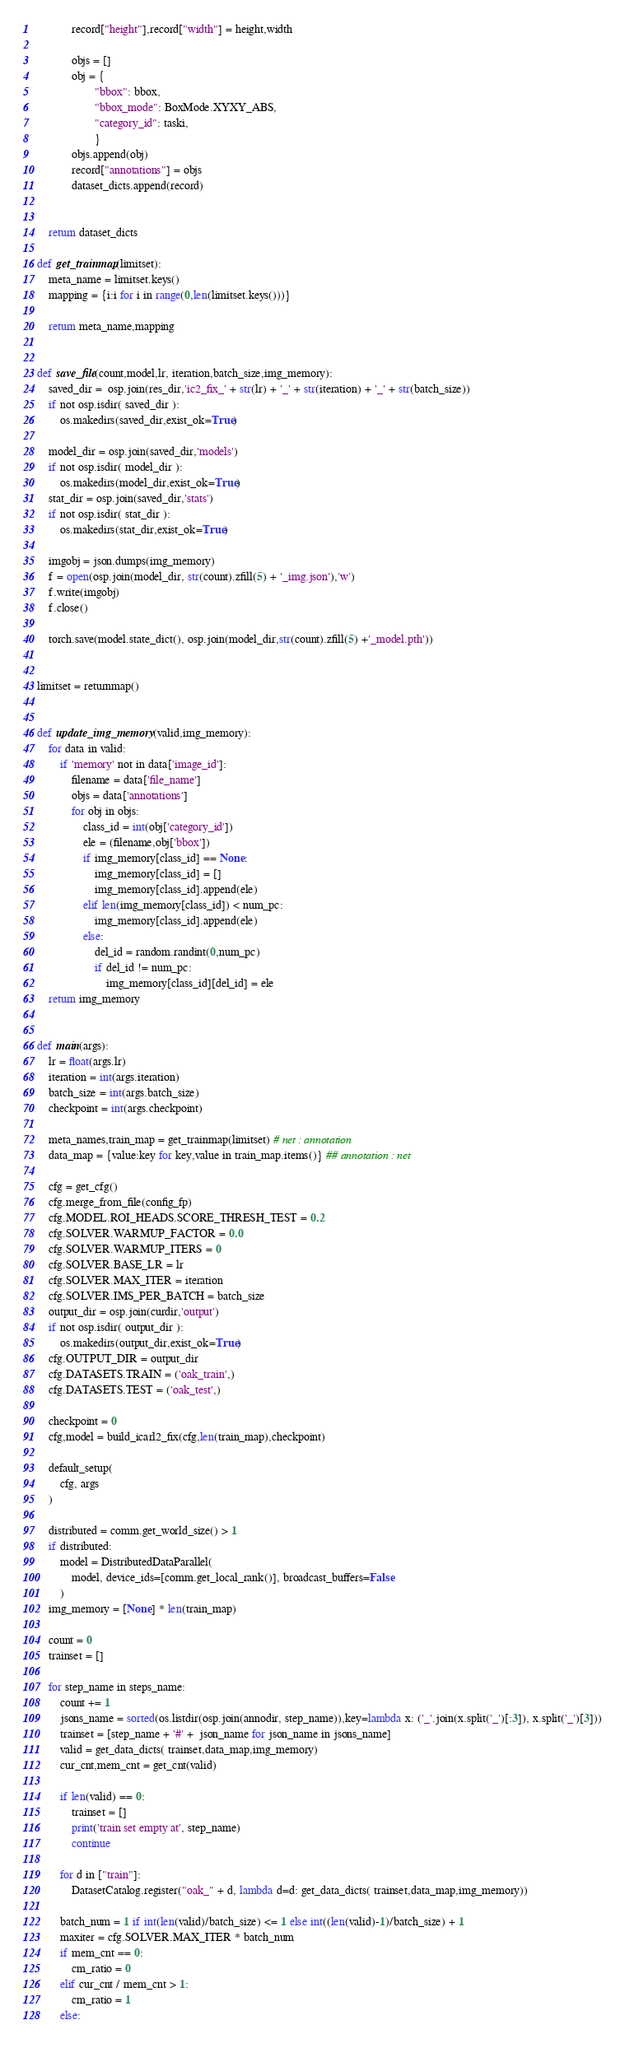<code> <loc_0><loc_0><loc_500><loc_500><_Python_>            record["height"],record["width"] = height,width

            objs = []
            obj = {
                    "bbox": bbox,
                    "bbox_mode": BoxMode.XYXY_ABS,
                    "category_id": taski,
                    }
            objs.append(obj)
            record["annotations"] = objs
            dataset_dicts.append(record)
    

    return dataset_dicts

def get_trainmap(limitset):
    meta_name = limitset.keys()
    mapping = {i:i for i in range(0,len(limitset.keys()))}

    return meta_name,mapping


def save_file(count,model,lr, iteration,batch_size,img_memory):
    saved_dir =  osp.join(res_dir,'ic2_fix_' + str(lr) + '_' + str(iteration) + '_' + str(batch_size))
    if not osp.isdir( saved_dir ):
        os.makedirs(saved_dir,exist_ok=True)

    model_dir = osp.join(saved_dir,'models')
    if not osp.isdir( model_dir ):
        os.makedirs(model_dir,exist_ok=True)
    stat_dir = osp.join(saved_dir,'stats')
    if not osp.isdir( stat_dir ):
        os.makedirs(stat_dir,exist_ok=True)

    imgobj = json.dumps(img_memory)
    f = open(osp.join(model_dir, str(count).zfill(5) + '_img.json'),'w')
    f.write(imgobj)
    f.close()

    torch.save(model.state_dict(), osp.join(model_dir,str(count).zfill(5) +'_model.pth'))


limitset = returnmap()


def update_img_memory(valid,img_memory):
    for data in valid:
        if 'memory' not in data['image_id']:
            filename = data['file_name']
            objs = data['annotations']
            for obj in objs:
                class_id = int(obj['category_id'])
                ele = (filename,obj['bbox'])
                if img_memory[class_id] == None:
                    img_memory[class_id] = []
                    img_memory[class_id].append(ele)     
                elif len(img_memory[class_id]) < num_pc:
                    img_memory[class_id].append(ele)          
                else:
                    del_id = random.randint(0,num_pc)
                    if del_id != num_pc:
                        img_memory[class_id][del_id] = ele
    return img_memory


def main(args):
    lr = float(args.lr)
    iteration = int(args.iteration)
    batch_size = int(args.batch_size)
    checkpoint = int(args.checkpoint)

    meta_names,train_map = get_trainmap(limitset) # net : annotation
    data_map = {value:key for key,value in train_map.items()} ## annotation : net

    cfg = get_cfg()
    cfg.merge_from_file(config_fp)
    cfg.MODEL.ROI_HEADS.SCORE_THRESH_TEST = 0.2
    cfg.SOLVER.WARMUP_FACTOR = 0.0
    cfg.SOLVER.WARMUP_ITERS = 0
    cfg.SOLVER.BASE_LR = lr
    cfg.SOLVER.MAX_ITER = iteration
    cfg.SOLVER.IMS_PER_BATCH = batch_size
    output_dir = osp.join(curdir,'output')
    if not osp.isdir( output_dir ):
        os.makedirs(output_dir,exist_ok=True)
    cfg.OUTPUT_DIR = output_dir
    cfg.DATASETS.TRAIN = ('oak_train',)
    cfg.DATASETS.TEST = ('oak_test',)

    checkpoint = 0
    cfg,model = build_icarl2_fix(cfg,len(train_map),checkpoint)
    
    default_setup(
        cfg, args
    )

    distributed = comm.get_world_size() > 1
    if distributed:
        model = DistributedDataParallel(
            model, device_ids=[comm.get_local_rank()], broadcast_buffers=False
        )
    img_memory = [None] * len(train_map)

    count = 0
    trainset = []
    
    for step_name in steps_name:
        count += 1
        jsons_name = sorted(os.listdir(osp.join(annodir, step_name)),key=lambda x: ('_'.join(x.split('_')[:3]), x.split('_')[3]))
        trainset = [step_name + '#' +  json_name for json_name in jsons_name]
        valid = get_data_dicts( trainset,data_map,img_memory)
        cur_cnt,mem_cnt = get_cnt(valid)

        if len(valid) == 0:
            trainset = []
            print('train set empty at', step_name)
            continue

        for d in ["train"]:
            DatasetCatalog.register("oak_" + d, lambda d=d: get_data_dicts( trainset,data_map,img_memory))

        batch_num = 1 if int(len(valid)/batch_size) <= 1 else int((len(valid)-1)/batch_size) + 1
        maxiter = cfg.SOLVER.MAX_ITER * batch_num
        if mem_cnt == 0:
            cm_ratio = 0
        elif cur_cnt / mem_cnt > 1:
            cm_ratio = 1
        else:</code> 